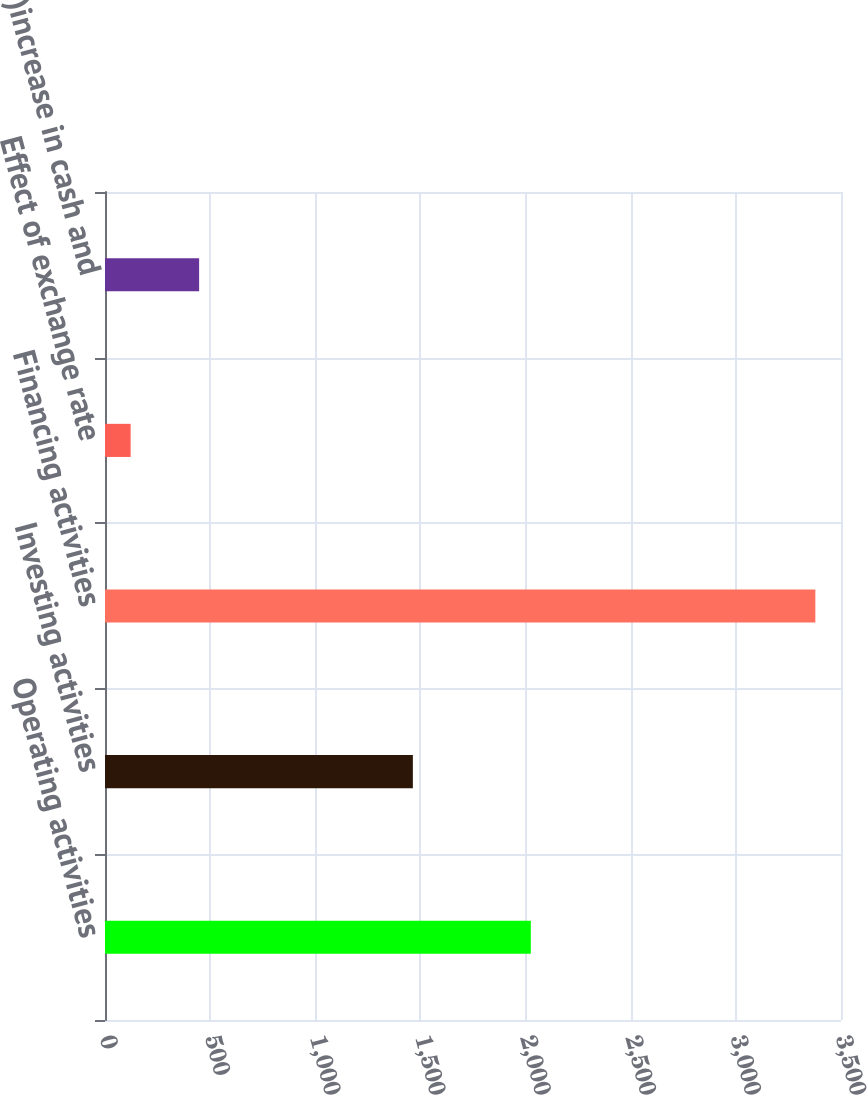<chart> <loc_0><loc_0><loc_500><loc_500><bar_chart><fcel>Operating activities<fcel>Investing activities<fcel>Financing activities<fcel>Effect of exchange rate<fcel>(Decrease)increase in cash and<nl><fcel>2025<fcel>1464<fcel>3378<fcel>122<fcel>447.6<nl></chart> 